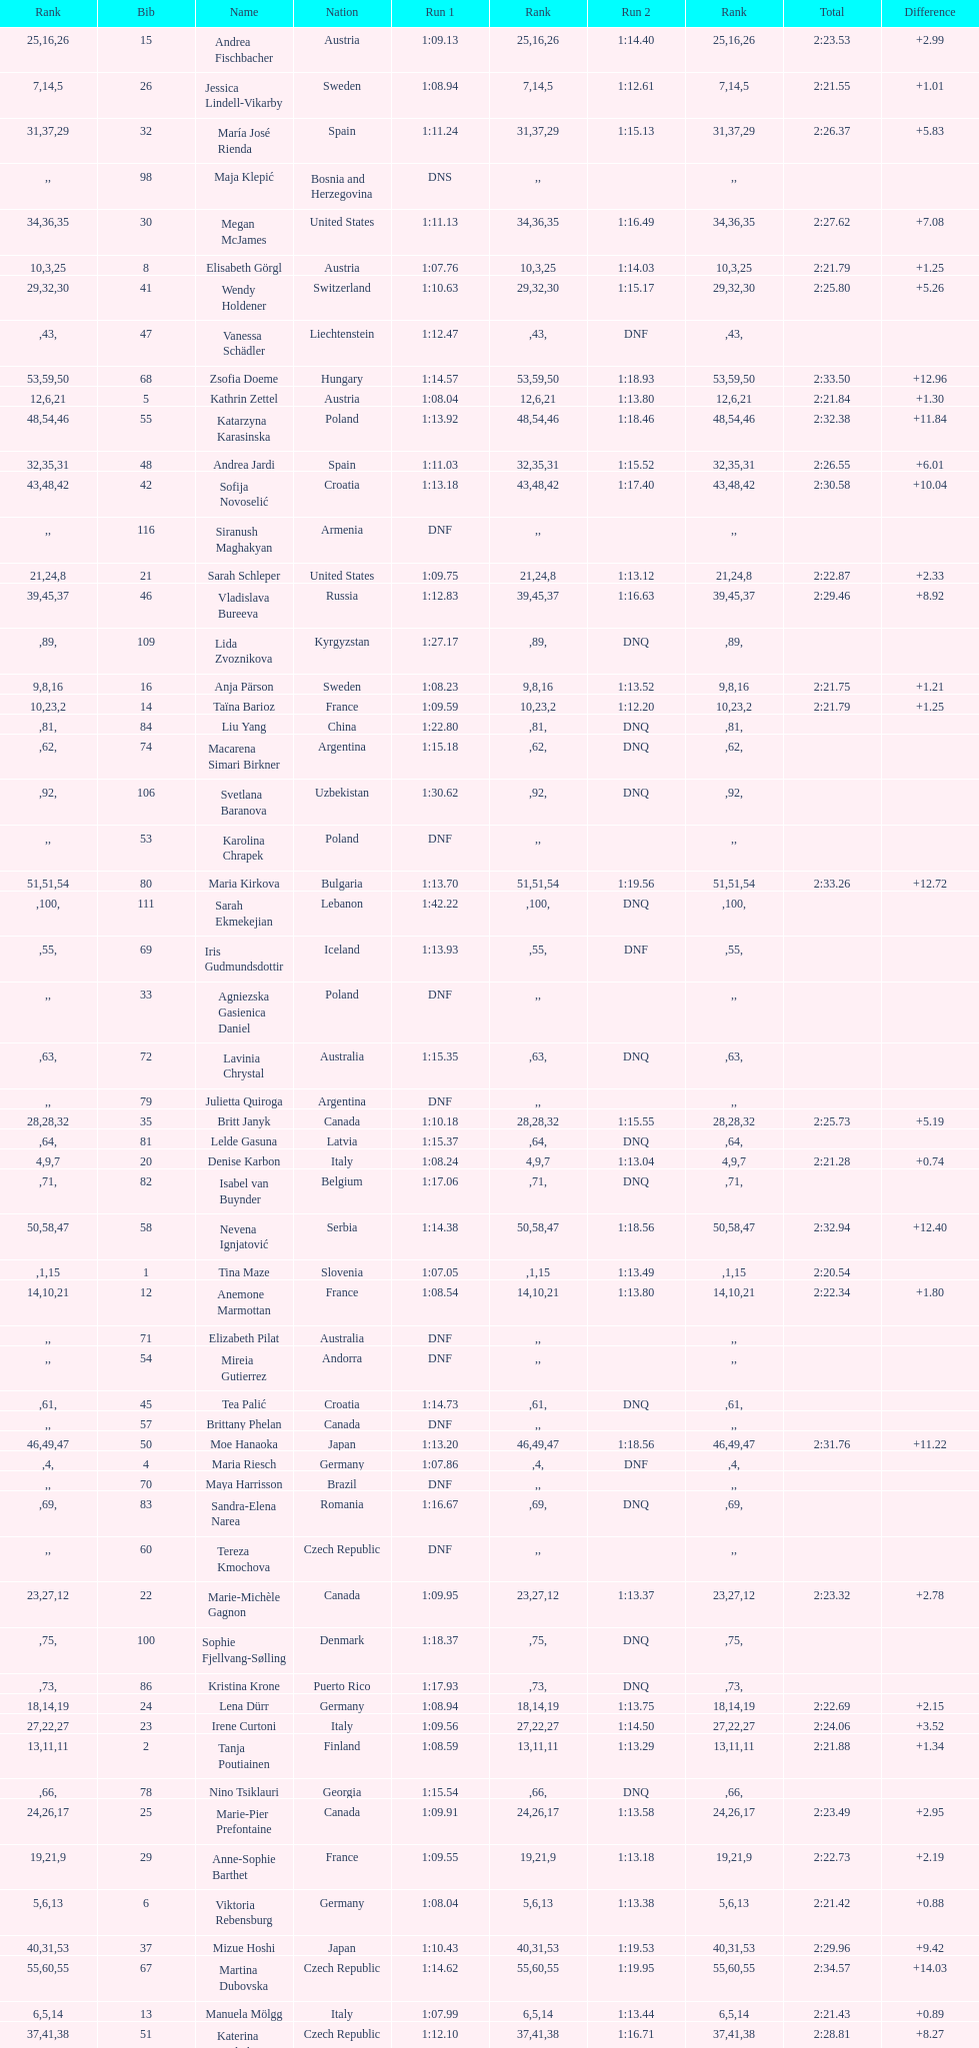Who was the last competitor to actually finish both runs? Martina Dubovska. 